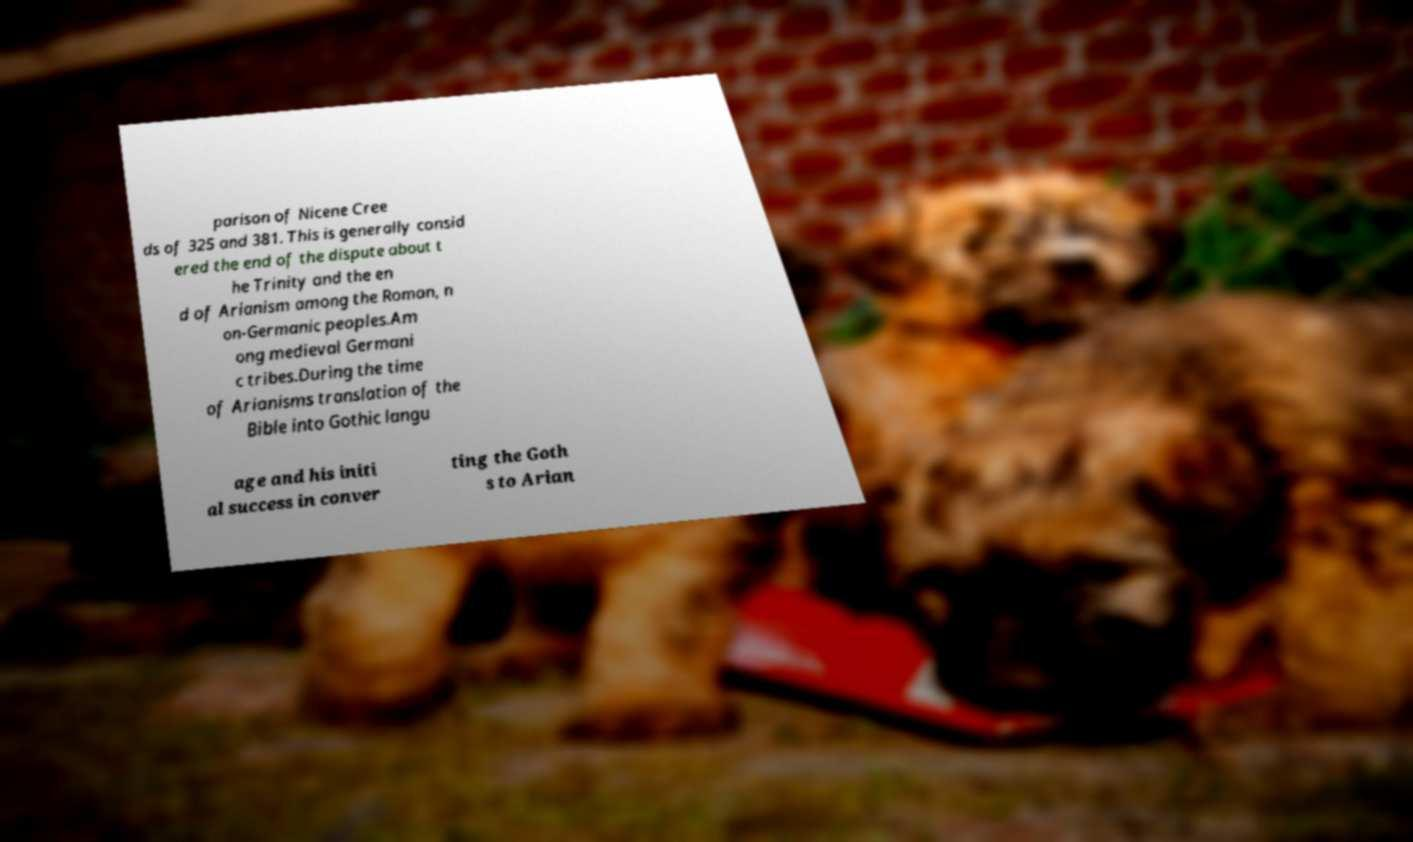Can you accurately transcribe the text from the provided image for me? parison of Nicene Cree ds of 325 and 381. This is generally consid ered the end of the dispute about t he Trinity and the en d of Arianism among the Roman, n on-Germanic peoples.Am ong medieval Germani c tribes.During the time of Arianisms translation of the Bible into Gothic langu age and his initi al success in conver ting the Goth s to Arian 